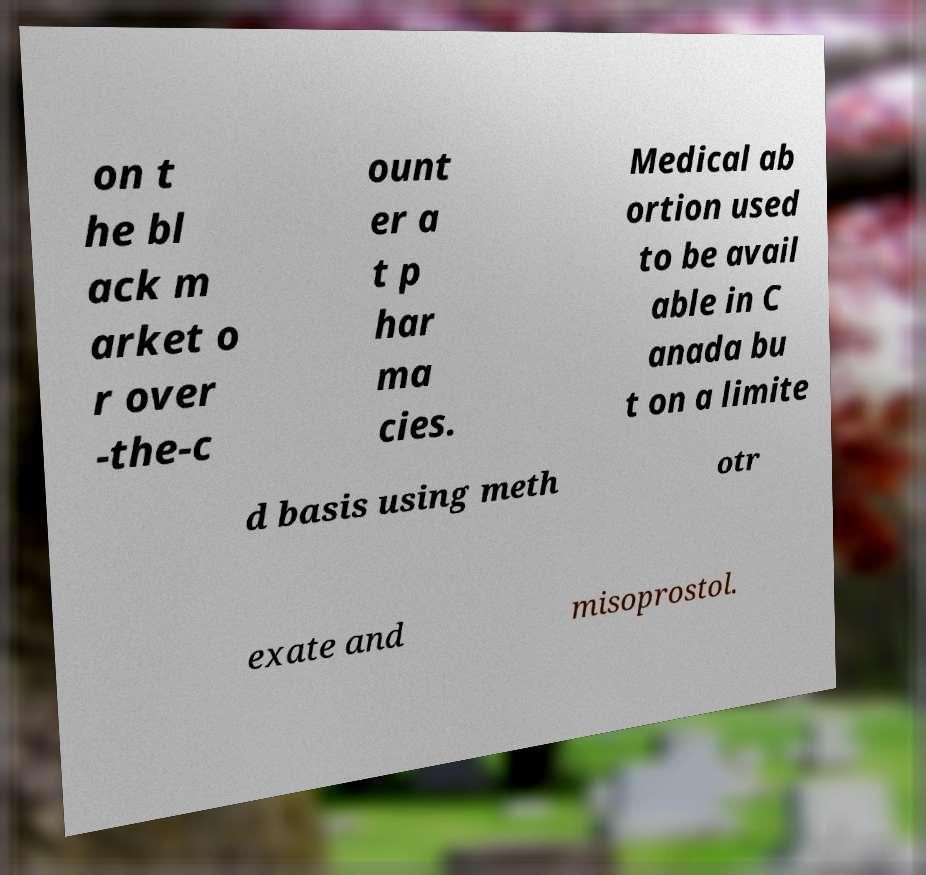I need the written content from this picture converted into text. Can you do that? on t he bl ack m arket o r over -the-c ount er a t p har ma cies. Medical ab ortion used to be avail able in C anada bu t on a limite d basis using meth otr exate and misoprostol. 